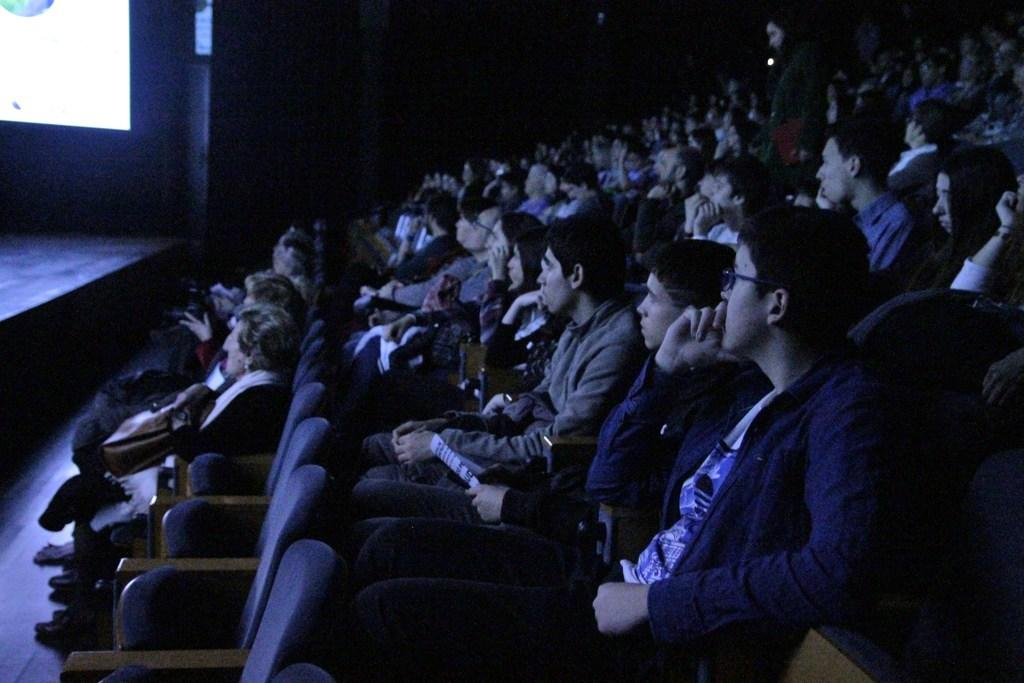How many people are in the image? There are multiple people in the image. What is the position of one person in the image? One person is standing. What are the other people doing in the image? The rest of the people are sitting on chairs. What can be seen on the screen in the image? The content on the screen cannot be determined from the provided facts. How would you describe the lighting in the image? The image appears to be slightly dark. What type of watch can be seen on the person's wrist in the image? There is no watch visible on anyone's wrist in the image. How does the fog affect the visibility in the image? There is no fog present in the image; it is slightly dark, but not due to fog. 